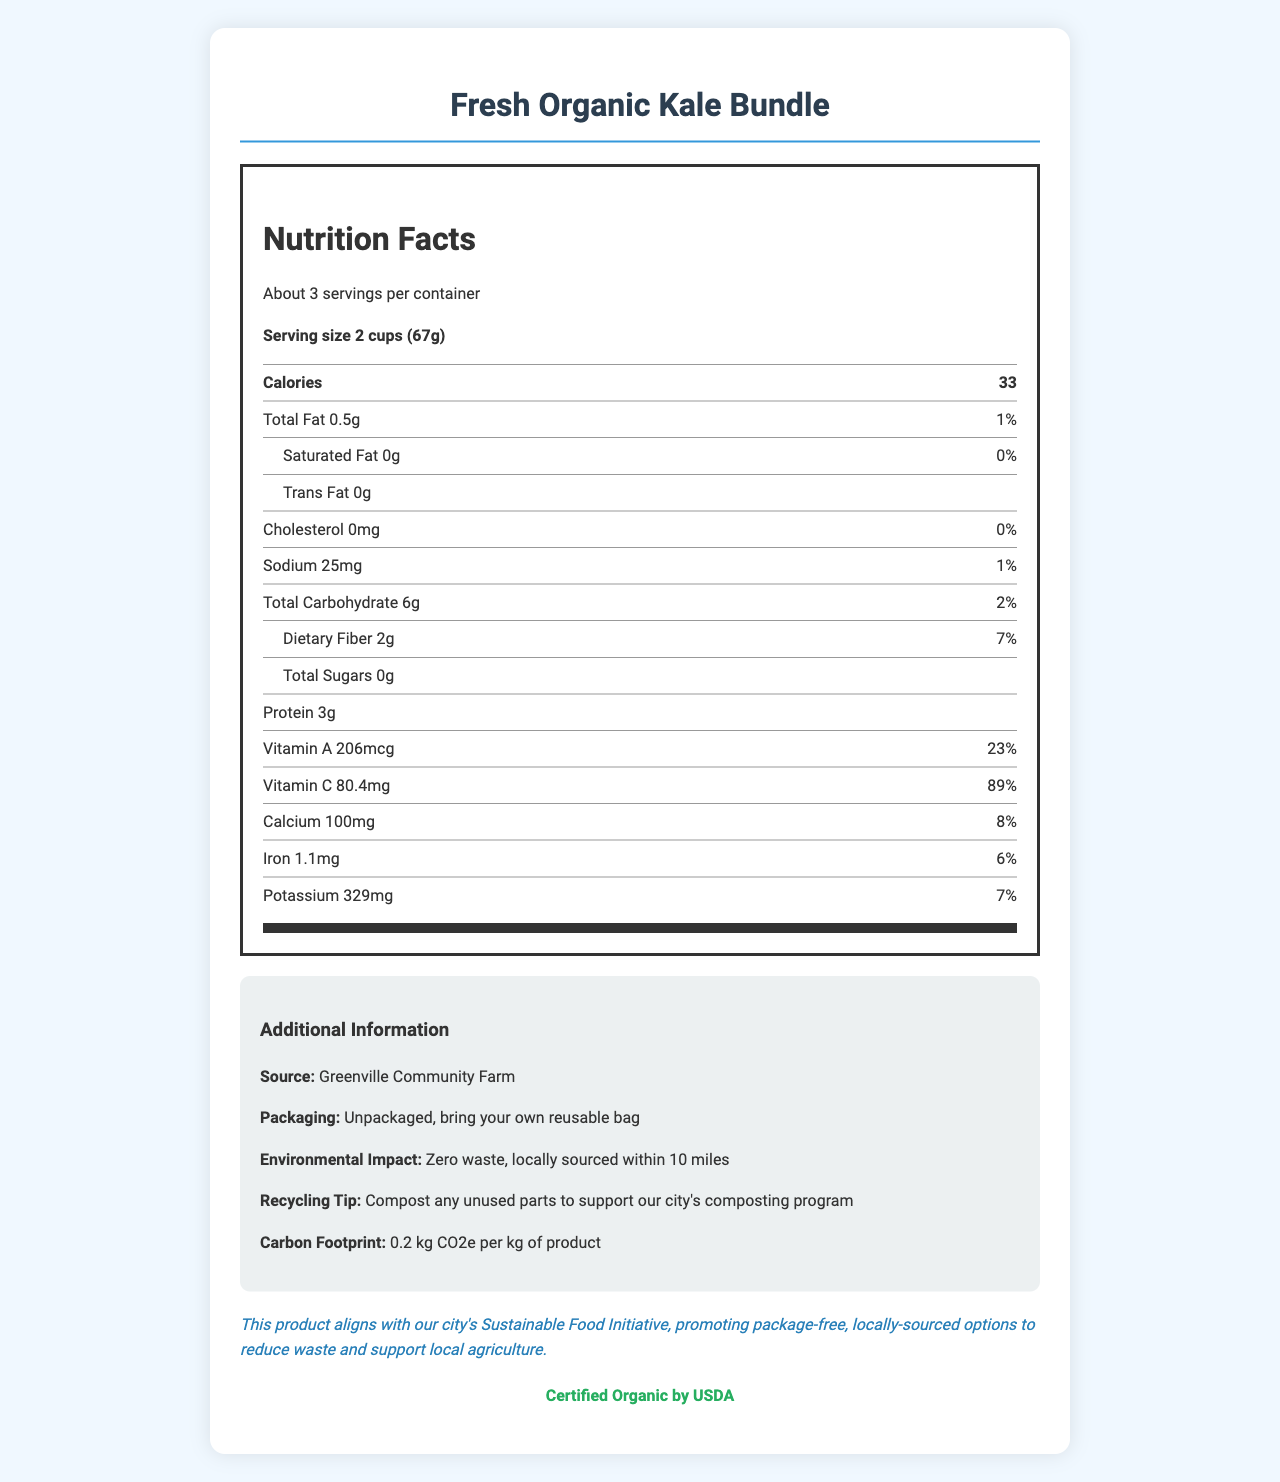how many calories are in one serving of Fresh Organic Kale Bundle? The nutrition label specifies that there are 33 calories per serving.
Answer: 33 calories what is the daily value percentage for Vitamin C? The nutrition label states that one serving provides 89% of the daily value of Vitamin C.
Answer: 89% how much dietary fiber is in one serving? The nutrition item listed shows that there are 2 grams of dietary fiber per serving.
Answer: 2g where is the Fresh Organic Kale Bundle sourced from? The additional information section indicates the source as Greenville Community Farm.
Answer: Greenville Community Farm what is the carbon footprint of this product per kilogram? The additional information mentions that the carbon footprint is 0.2 kg CO2e per kg of product.
Answer: 0.2 kg CO2e per kg of product how many servings are in one container? A. 1 B. 2 C. About 3 D. 4 The document states that there are about 3 servings per container.
Answer: C. About 3 what is the correct daily value percentage for sodium? A. 1% B. 5% C. 10% D. 15% The nutrition label shows that the daily value percentage for sodium is 1%.
Answer: A. 1% is this product certified organic by USDA? The document explicitly states that the product is certified organic by USDA.
Answer: Yes does the product come in packaging? The additional info indicates that the product is unpackaged and consumers are encouraged to bring their own reusable bag.
Answer: No describe the main idea of the document The document combines nutritional data with environmental benefits and local policy alignment to promote a sustainable and healthy product.
Answer: The document provides detailed nutritional information for Fresh Organic Kale Bundle, including serving size, caloric content, and percentages of daily values for various nutrients. It also highlights the environmental benefits such as being locally sourced from Greenville Community Farm, unpackaged to promote zero waste, and features a low carbon footprint. Additionally, it aligns with the city's Sustainable Food Initiative and offers composting tips. what are the health benefits of kale? The document does not provide information about the specific health benefits of kale, only its nutritional content and environmental impact.
Answer: I don't know 